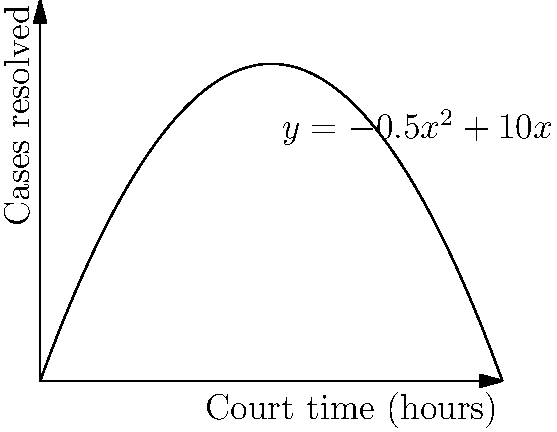As a passionate local resident advocating for fair trials, you're analyzing the efficiency of court time allocation. The function $y = -0.5x^2 + 10x$ represents the number of cases resolved (y) in relation to the number of hours the court is in session (x). What is the optimal number of court hours to maximize the number of cases resolved, and how many cases will be resolved at this optimal point? To find the optimal number of court hours and the maximum number of cases resolved, we need to follow these steps:

1) The function given is $y = -0.5x^2 + 10x$, which is a quadratic function.

2) To find the maximum point, we need to find the vertex of this parabola. For a quadratic function in the form $y = ax^2 + bx + c$, the x-coordinate of the vertex is given by $x = -\frac{b}{2a}$.

3) In our case, $a = -0.5$ and $b = 10$. So:

   $x = -\frac{10}{2(-0.5)} = -\frac{10}{-1} = 10$

4) This means the optimal number of court hours is 10.

5) To find how many cases will be resolved at this point, we substitute x = 10 into the original function:

   $y = -0.5(10)^2 + 10(10)$
   $y = -0.5(100) + 100$
   $y = -50 + 100 = 50$

Therefore, the optimal number of court hours is 10, and at this point, 50 cases will be resolved.
Answer: 10 hours; 50 cases 